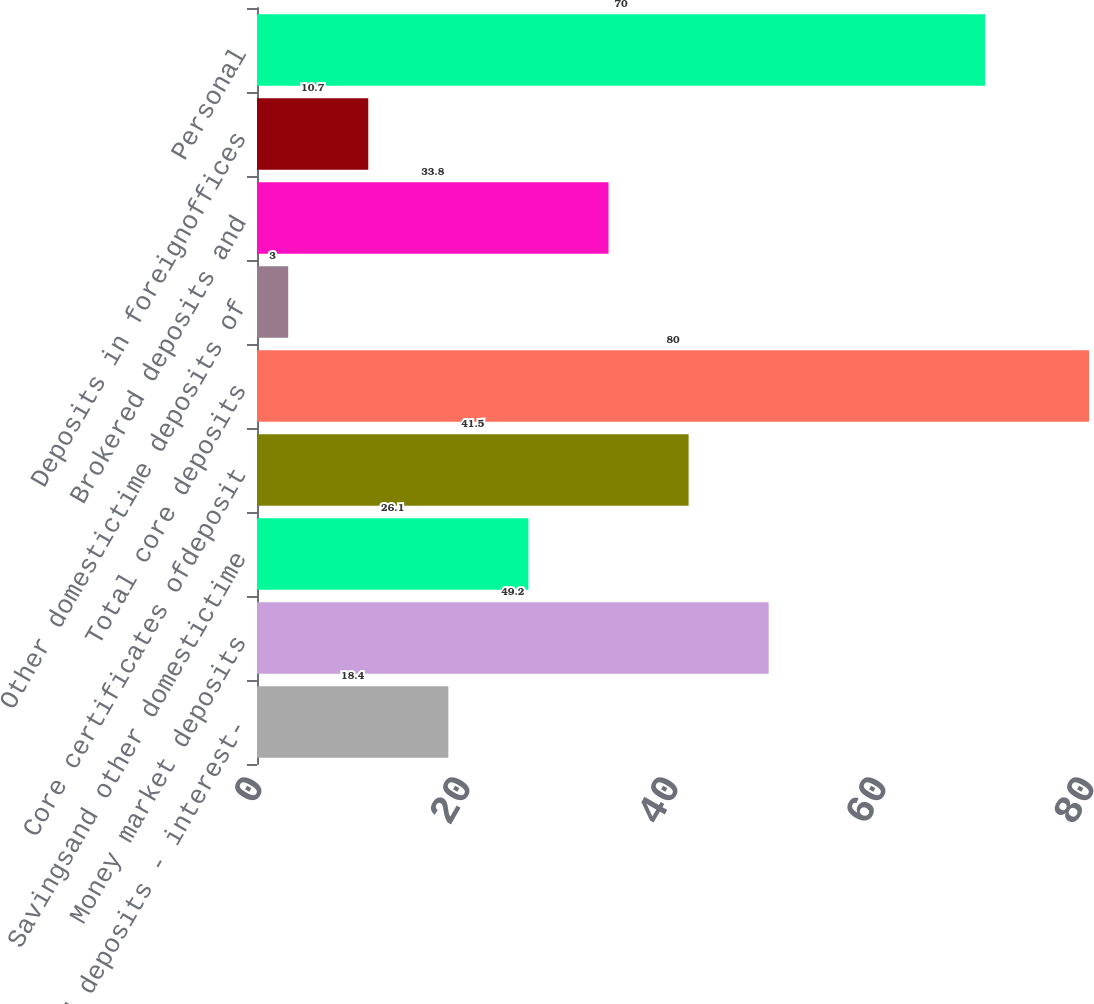<chart> <loc_0><loc_0><loc_500><loc_500><bar_chart><fcel>Demand deposits - interest-<fcel>Money market deposits<fcel>Savingsand other domestictime<fcel>Core certificates ofdeposit<fcel>Total core deposits<fcel>Other domestictime deposits of<fcel>Brokered deposits and<fcel>Deposits in foreignoffices<fcel>Personal<nl><fcel>18.4<fcel>49.2<fcel>26.1<fcel>41.5<fcel>80<fcel>3<fcel>33.8<fcel>10.7<fcel>70<nl></chart> 